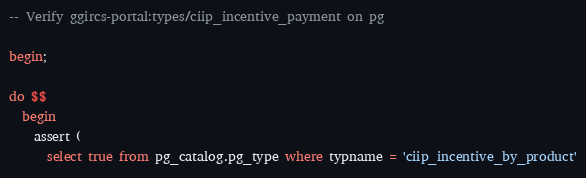<code> <loc_0><loc_0><loc_500><loc_500><_SQL_>-- Verify ggircs-portal:types/ciip_incentive_payment on pg

begin;

do $$
  begin
    assert (
      select true from pg_catalog.pg_type where typname = 'ciip_incentive_by_product'</code> 